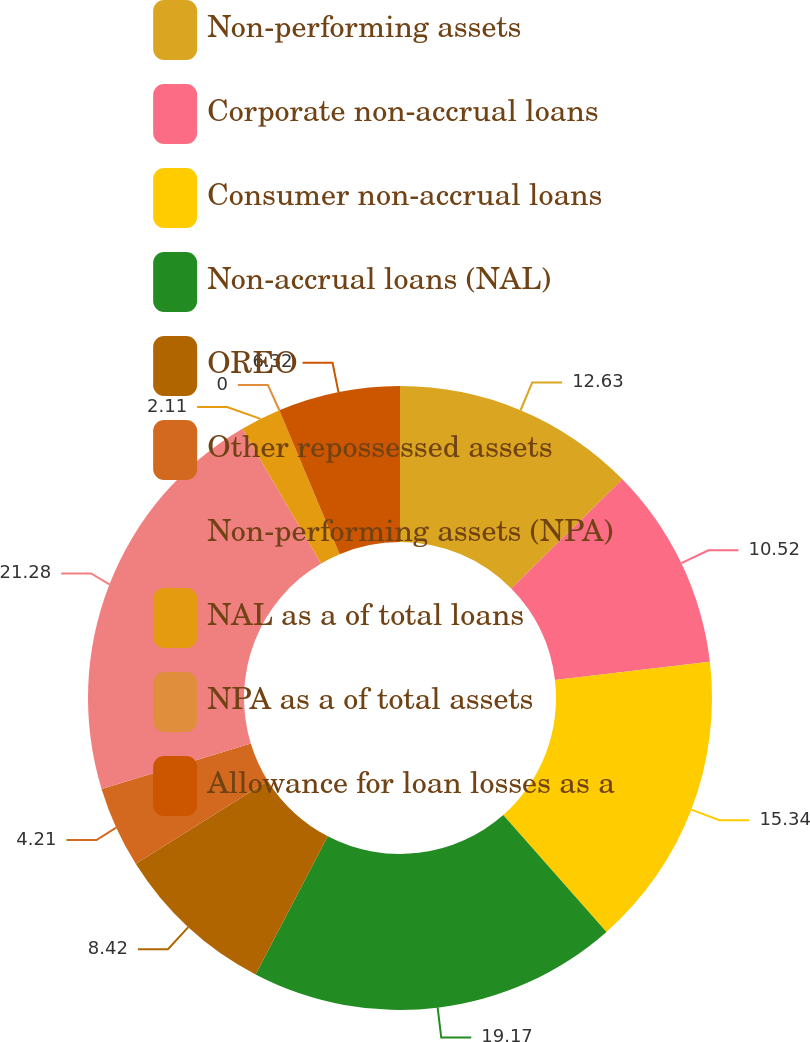<chart> <loc_0><loc_0><loc_500><loc_500><pie_chart><fcel>Non-performing assets<fcel>Corporate non-accrual loans<fcel>Consumer non-accrual loans<fcel>Non-accrual loans (NAL)<fcel>OREO<fcel>Other repossessed assets<fcel>Non-performing assets (NPA)<fcel>NAL as a of total loans<fcel>NPA as a of total assets<fcel>Allowance for loan losses as a<nl><fcel>12.63%<fcel>10.52%<fcel>15.34%<fcel>19.17%<fcel>8.42%<fcel>4.21%<fcel>21.28%<fcel>2.11%<fcel>0.0%<fcel>6.32%<nl></chart> 